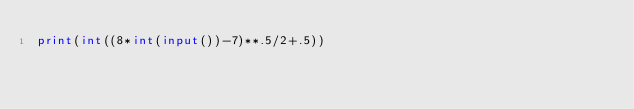Convert code to text. <code><loc_0><loc_0><loc_500><loc_500><_Python_>print(int((8*int(input())-7)**.5/2+.5))</code> 